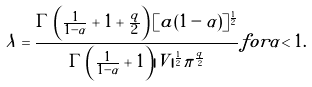Convert formula to latex. <formula><loc_0><loc_0><loc_500><loc_500>\lambda = \frac { \Gamma \left ( \frac { 1 } { 1 - \alpha } + 1 + \frac { q } { 2 } \right ) [ a ( 1 - \alpha ) ] ^ { \frac { 1 } { 2 } } } { \Gamma \left ( \frac { 1 } { 1 - \alpha } + 1 \right ) | V | ^ { \frac { 1 } { 2 } } \pi ^ { \frac { q } { 2 } } } f o r \alpha < 1 .</formula> 